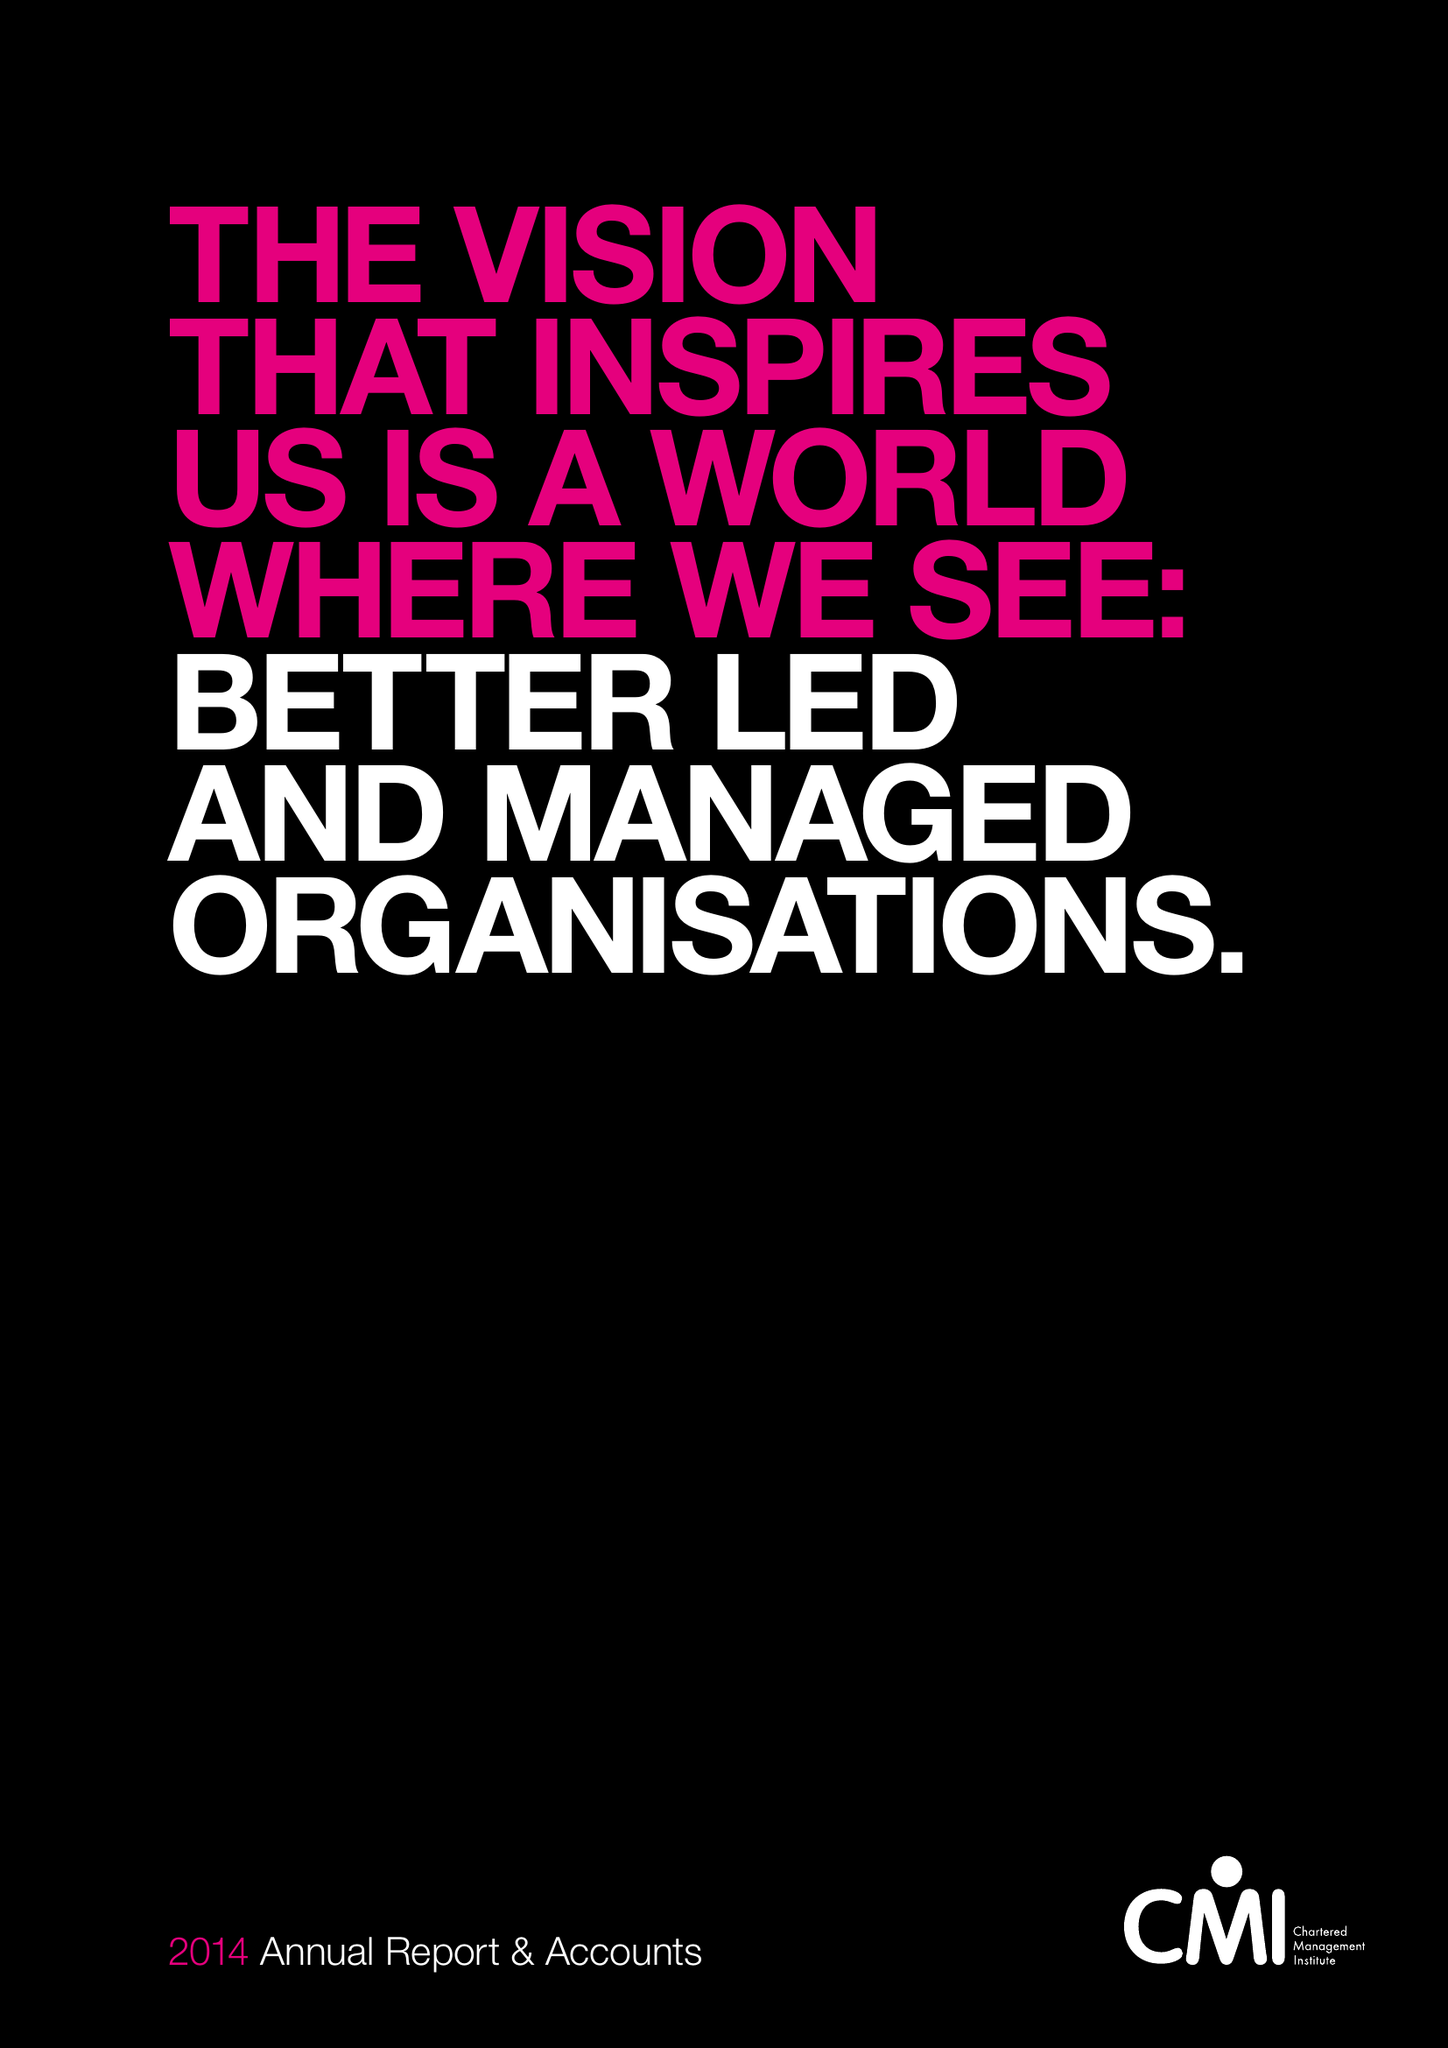What is the value for the address__street_line?
Answer the question using a single word or phrase. COTTINGHAM ROAD 